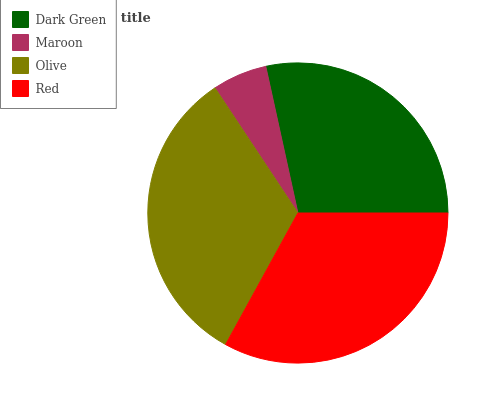Is Maroon the minimum?
Answer yes or no. Yes. Is Red the maximum?
Answer yes or no. Yes. Is Olive the minimum?
Answer yes or no. No. Is Olive the maximum?
Answer yes or no. No. Is Olive greater than Maroon?
Answer yes or no. Yes. Is Maroon less than Olive?
Answer yes or no. Yes. Is Maroon greater than Olive?
Answer yes or no. No. Is Olive less than Maroon?
Answer yes or no. No. Is Olive the high median?
Answer yes or no. Yes. Is Dark Green the low median?
Answer yes or no. Yes. Is Red the high median?
Answer yes or no. No. Is Maroon the low median?
Answer yes or no. No. 